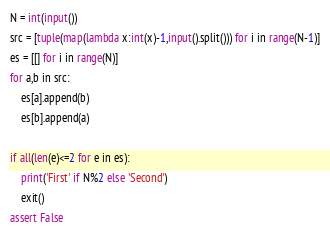<code> <loc_0><loc_0><loc_500><loc_500><_Python_>N = int(input())
src = [tuple(map(lambda x:int(x)-1,input().split())) for i in range(N-1)]
es = [[] for i in range(N)]
for a,b in src:
    es[a].append(b)
    es[b].append(a)

if all(len(e)<=2 for e in es):
    print('First' if N%2 else 'Second')
    exit()
assert False</code> 